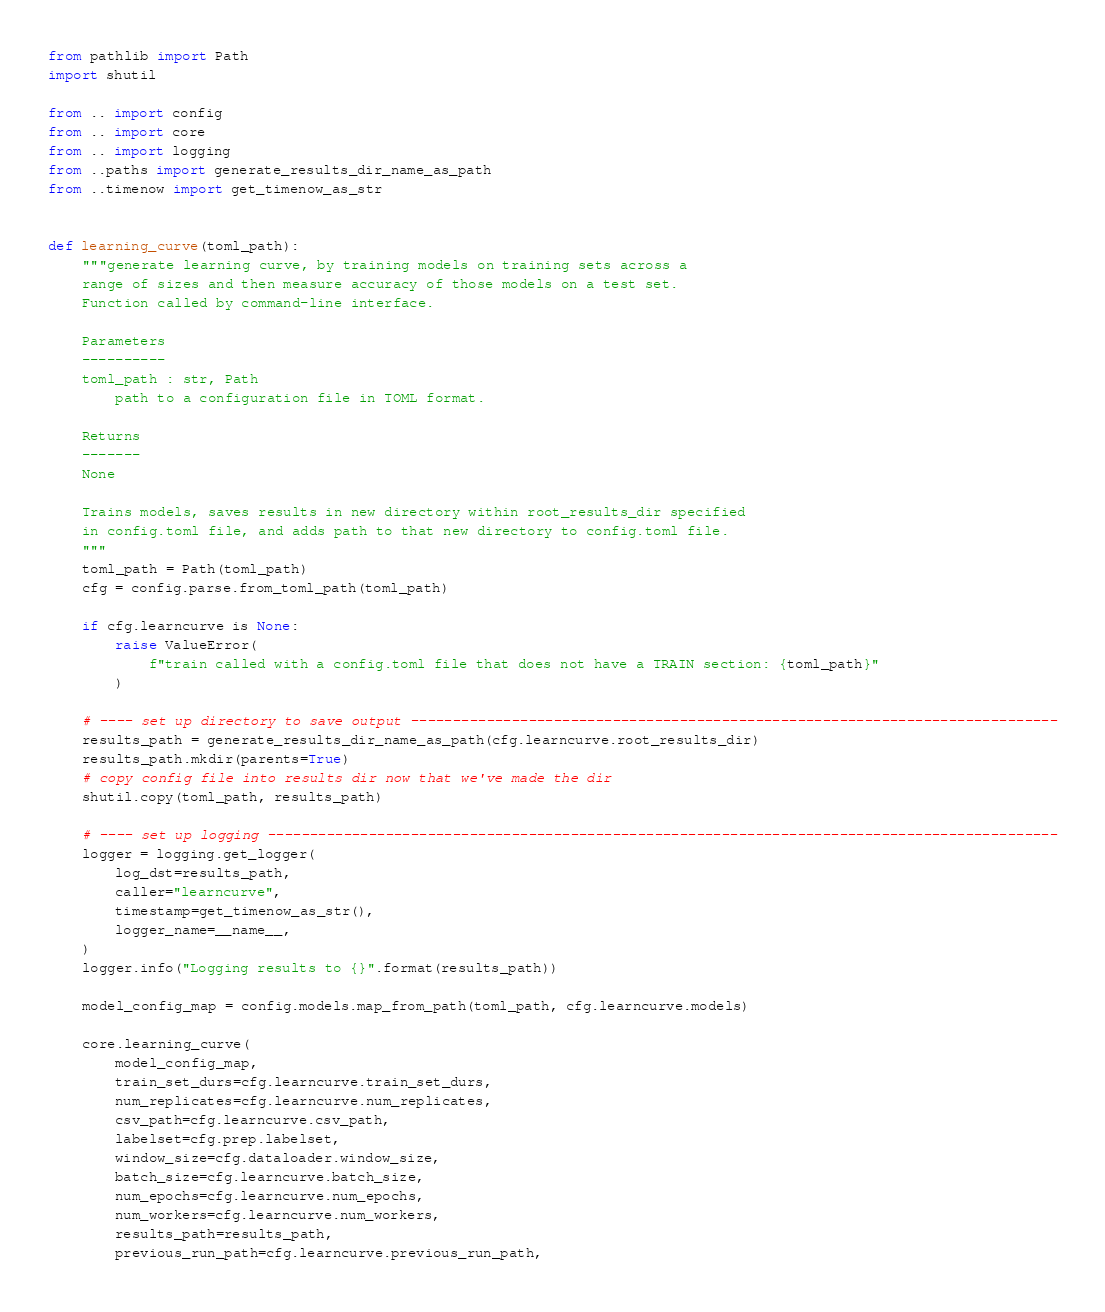Convert code to text. <code><loc_0><loc_0><loc_500><loc_500><_Python_>from pathlib import Path
import shutil

from .. import config
from .. import core
from .. import logging
from ..paths import generate_results_dir_name_as_path
from ..timenow import get_timenow_as_str


def learning_curve(toml_path):
    """generate learning curve, by training models on training sets across a
    range of sizes and then measure accuracy of those models on a test set.
    Function called by command-line interface.

    Parameters
    ----------
    toml_path : str, Path
        path to a configuration file in TOML format.

    Returns
    -------
    None

    Trains models, saves results in new directory within root_results_dir specified
    in config.toml file, and adds path to that new directory to config.toml file.
    """
    toml_path = Path(toml_path)
    cfg = config.parse.from_toml_path(toml_path)

    if cfg.learncurve is None:
        raise ValueError(
            f"train called with a config.toml file that does not have a TRAIN section: {toml_path}"
        )

    # ---- set up directory to save output -----------------------------------------------------------------------------
    results_path = generate_results_dir_name_as_path(cfg.learncurve.root_results_dir)
    results_path.mkdir(parents=True)
    # copy config file into results dir now that we've made the dir
    shutil.copy(toml_path, results_path)

    # ---- set up logging ----------------------------------------------------------------------------------------------
    logger = logging.get_logger(
        log_dst=results_path,
        caller="learncurve",
        timestamp=get_timenow_as_str(),
        logger_name=__name__,
    )
    logger.info("Logging results to {}".format(results_path))

    model_config_map = config.models.map_from_path(toml_path, cfg.learncurve.models)

    core.learning_curve(
        model_config_map,
        train_set_durs=cfg.learncurve.train_set_durs,
        num_replicates=cfg.learncurve.num_replicates,
        csv_path=cfg.learncurve.csv_path,
        labelset=cfg.prep.labelset,
        window_size=cfg.dataloader.window_size,
        batch_size=cfg.learncurve.batch_size,
        num_epochs=cfg.learncurve.num_epochs,
        num_workers=cfg.learncurve.num_workers,
        results_path=results_path,
        previous_run_path=cfg.learncurve.previous_run_path,</code> 